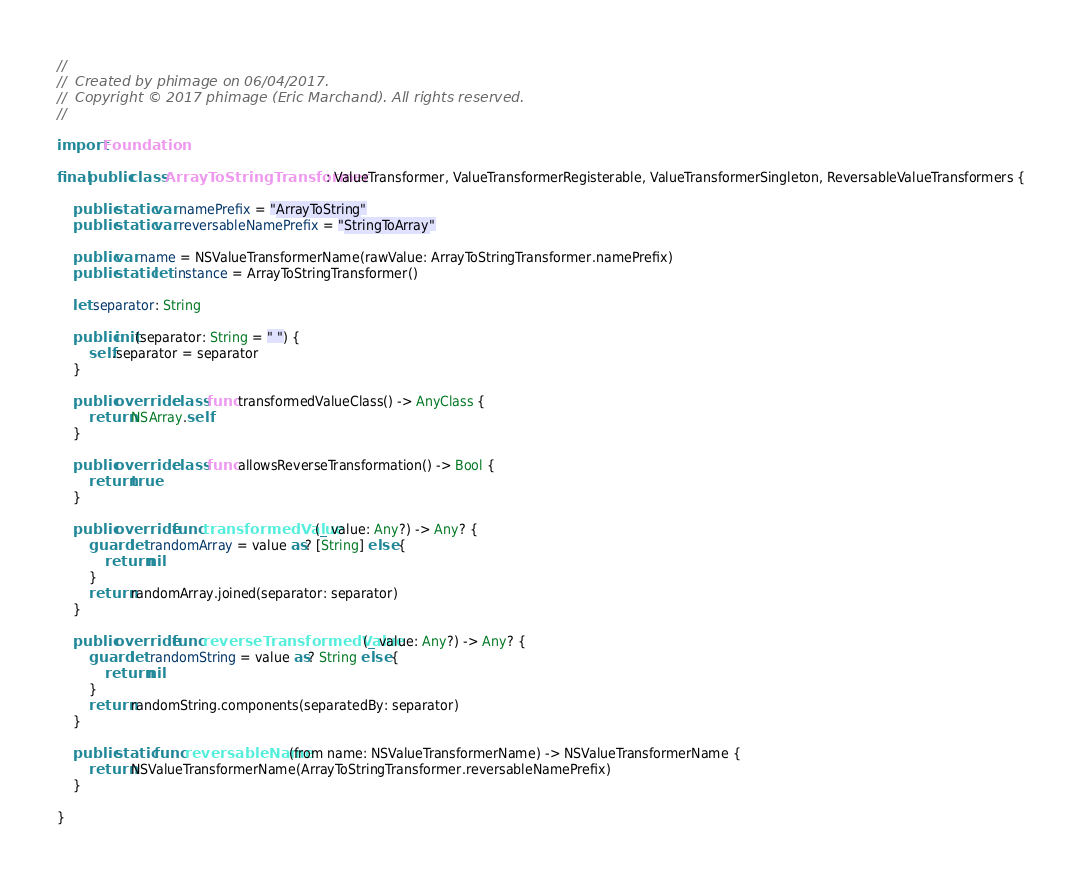<code> <loc_0><loc_0><loc_500><loc_500><_Swift_>//
//  Created by phimage on 06/04/2017.
//  Copyright © 2017 phimage (Eric Marchand). All rights reserved.
//

import Foundation

final public class ArrayToStringTransformer: ValueTransformer, ValueTransformerRegisterable, ValueTransformerSingleton, ReversableValueTransformers {

    public static var namePrefix = "ArrayToString"
    public static var reversableNamePrefix = "StringToArray"

    public var name = NSValueTransformerName(rawValue: ArrayToStringTransformer.namePrefix)
    public static let instance = ArrayToStringTransformer()

    let separator: String

    public init(separator: String = " ") {
        self.separator = separator
    }

    public override class func transformedValueClass() -> AnyClass {
        return NSArray.self
    }

    public override class func allowsReverseTransformation() -> Bool {
        return true
    }

    public override func transformedValue(_ value: Any?) -> Any? {
        guard let randomArray = value as? [String] else {
            return nil
        }
        return randomArray.joined(separator: separator)
    }

    public override func reverseTransformedValue(_ value: Any?) -> Any? {
        guard let randomString = value as? String else {
            return nil
        }
        return randomString.components(separatedBy: separator)
    }

    public static func reversableName(from name: NSValueTransformerName) -> NSValueTransformerName {
        return NSValueTransformerName(ArrayToStringTransformer.reversableNamePrefix)
    }

}
</code> 